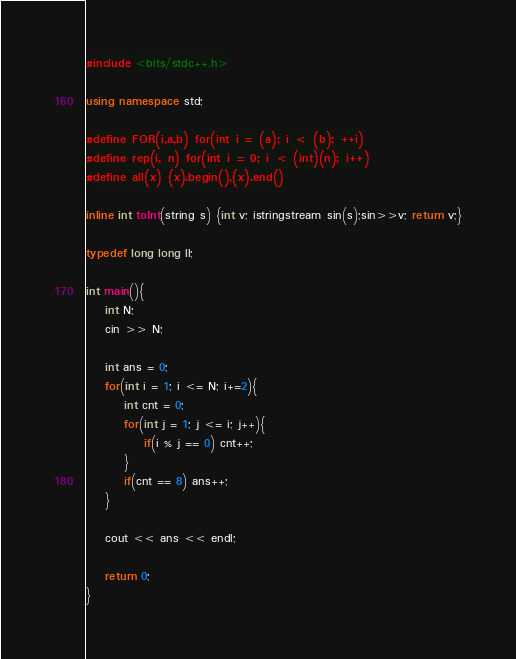Convert code to text. <code><loc_0><loc_0><loc_500><loc_500><_C++_>#include <bits/stdc++.h>

using namespace std;

#define FOR(i,a,b) for(int i = (a); i < (b); ++i)
#define rep(i, n) for(int i = 0; i < (int)(n); i++)
#define all(x) (x).begin(),(x).end()

inline int toInt(string s) {int v; istringstream sin(s);sin>>v; return v;}

typedef long long ll;

int main(){
    int N;
    cin >> N;

    int ans = 0;
    for(int i = 1; i <= N; i+=2){
        int cnt = 0;
        for(int j = 1; j <= i; j++){
            if(i % j == 0) cnt++;
        }
        if(cnt == 8) ans++;
    }

    cout << ans << endl;

    return 0;
}</code> 